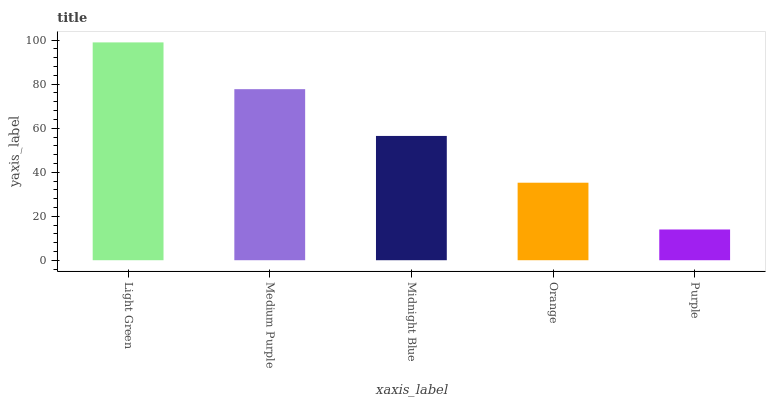Is Purple the minimum?
Answer yes or no. Yes. Is Light Green the maximum?
Answer yes or no. Yes. Is Medium Purple the minimum?
Answer yes or no. No. Is Medium Purple the maximum?
Answer yes or no. No. Is Light Green greater than Medium Purple?
Answer yes or no. Yes. Is Medium Purple less than Light Green?
Answer yes or no. Yes. Is Medium Purple greater than Light Green?
Answer yes or no. No. Is Light Green less than Medium Purple?
Answer yes or no. No. Is Midnight Blue the high median?
Answer yes or no. Yes. Is Midnight Blue the low median?
Answer yes or no. Yes. Is Purple the high median?
Answer yes or no. No. Is Orange the low median?
Answer yes or no. No. 